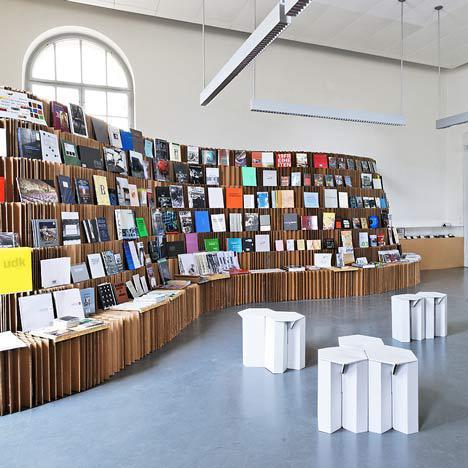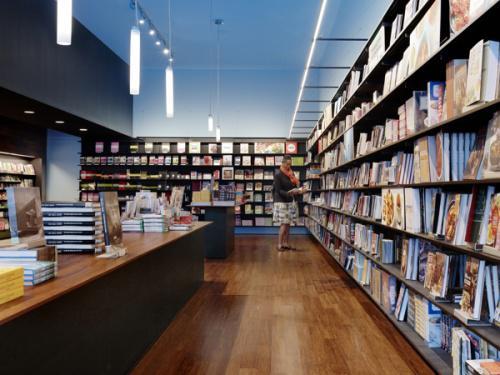The first image is the image on the left, the second image is the image on the right. Analyze the images presented: Is the assertion "Atleast one building has a wooden floor." valid? Answer yes or no. Yes. The first image is the image on the left, the second image is the image on the right. For the images shown, is this caption "There is seating visible in at least one of the images." true? Answer yes or no. Yes. 